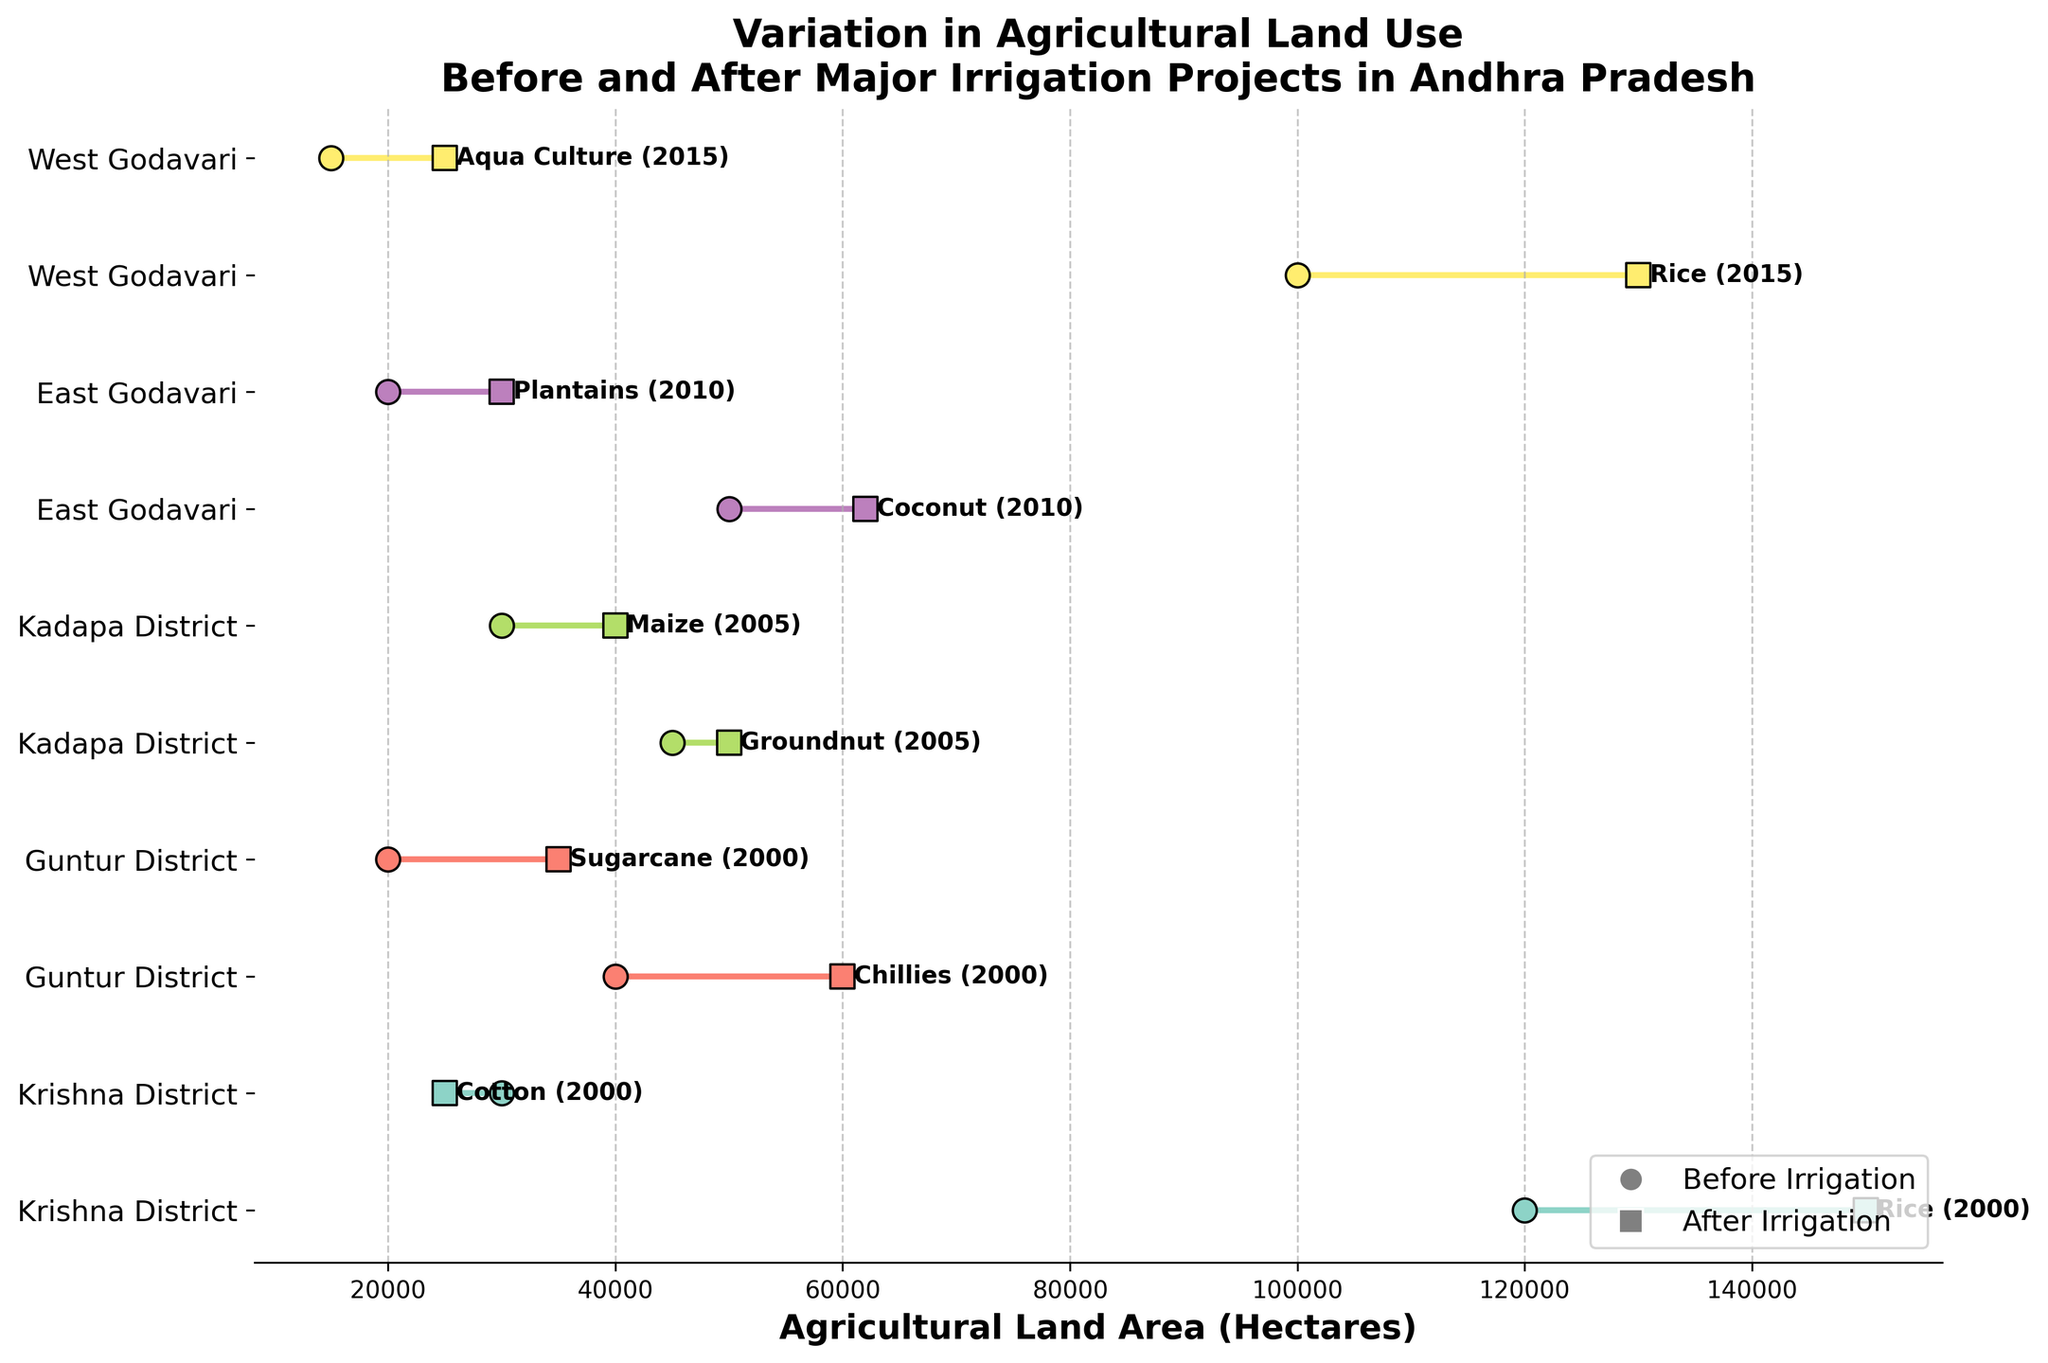What's the title of the plot? The title is displayed prominently at the top of the plot and summarizes the content, which is about the variation in agricultural land use before and after major irrigation projects in Andhra Pradesh.
Answer: Variation in Agricultural Land Use Before and After Major Irrigation Projects in Andhra Pradesh How many regions are represented in the plot? By counting the unique region labels along the y-axis, we can determine the number of regions depicted in the plot.
Answer: 5 Which crop in Guntur District saw the largest increase in agricultural area after irrigation? By comparing the before and after areas for both crops in the Guntur District, we can see that Chillies increased from 40,000 to 60,000 hectares, while Sugarcane increased from 20,000 to 35,000 hectares. Chillies thus saw the largest increase.
Answer: Chillies Which crop in West Godavari had the least agricultural area before irrigation? By looking at the before irrigation areas in West Godavari, we find that Rice had 100,000 hectares and Aqua Culture had 15,000 hectares, making Aqua Culture the least.
Answer: Aqua Culture What is the difference in agricultural area for Groundnut in Kadapa District before and after irrigation? The before and after irrigation areas for Groundnut in Kadapa District are 45,000 and 50,000 hectares, respectively. The difference can be calculated by subtracting the former from the latter: 50,000 - 45,000.
Answer: 5,000 hectares How does the change in Maize area compare to the change in Groundnut area in Kadapa District? By finding the difference in area before and after irrigation for both crops, we know Groundnut increased by 5,000 hectares (50,000 - 45,000), and Maize increased by 10,000 hectares (40,000 - 30,000). Therefore, Maize saw a greater increase.
Answer: Maize increased more Which region had the highest increase in agricultural area for any given crop? We need to find the crop with the highest difference between before and after irrigation in all regions. Comparing the differences, Chillies in Guntur District had the largest increase from 40,000 to 60,000 hectares, an increase of 20,000 hectares.
Answer: Guntur District (Chillies) What year is associated with the data for Chillies in Guntur District? The year can be found in the plot text beside the Chillies data points in Guntur District.
Answer: 2000 Which region had the smallest variation in land use for any crop after irrigation projects? By calculating the differences in all pairs of data points, Groundnut in Kadapa District had a small variation of 5,000 hectares (50,000 - 45,000), which is the smallest change.
Answer: Kadapa District (Groundnut) How many crops are represented in the plot? By counting the unique crop labels scattered beside the data points in the plot, we can determine the number of different crops shown.
Answer: 10 